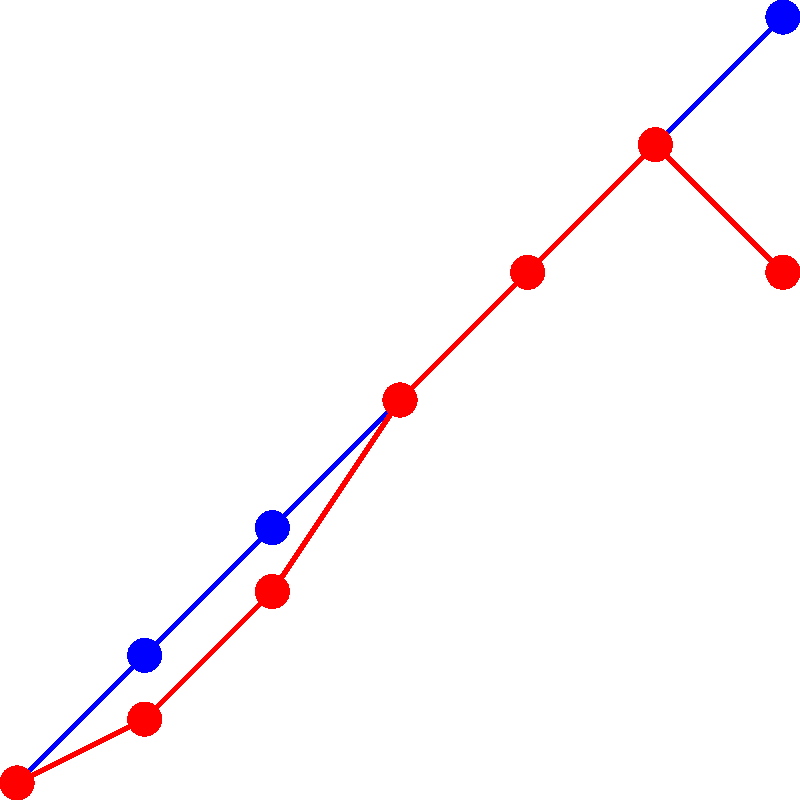Based on the timeline shown in the graph, at which point during World War II did local community changes reach their peak, and how does this correlate with major wartime events? To answer this question, we need to analyze the graph step-by-step:

1. The blue line represents major WWII events, while the red line shows local community changes.

2. Examine the red line (local community changes):
   - It starts at 0 in 1939 and gradually increases until 1944.
   - The peak of the red line occurs in 1944.
   - After 1944, there's a slight decrease.

3. Compare this with the blue line (major WWII events):
   - The blue line shows a steady increase throughout the war.
   - In 1944, when local community changes peak, major war events are also at a high point.

4. Interpret the correlation:
   - The peak in local community changes coincides with a period of intense war activity.
   - This suggests that as the war intensified, its impact on local communities also increased.

5. Historical context:
   - 1944 saw significant events like D-Day and the liberation of France, which likely had far-reaching effects on many communities.

6. Post-peak analysis:
   - The slight decrease in community changes after 1944 might indicate the beginning of recovery as the war neared its end in 1945.
Answer: 1944; peak community changes correlate with intensified war activities. 